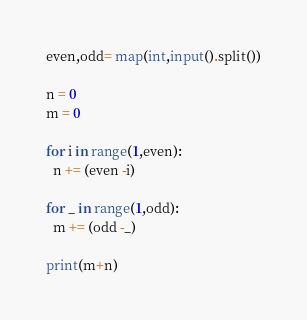Convert code to text. <code><loc_0><loc_0><loc_500><loc_500><_Python_>even,odd= map(int,input().split())

n = 0
m = 0

for i in range(1,even):
  n += (even -i)

for _ in range(1,odd):
  m += (odd -_)
  
print(m+n)
</code> 